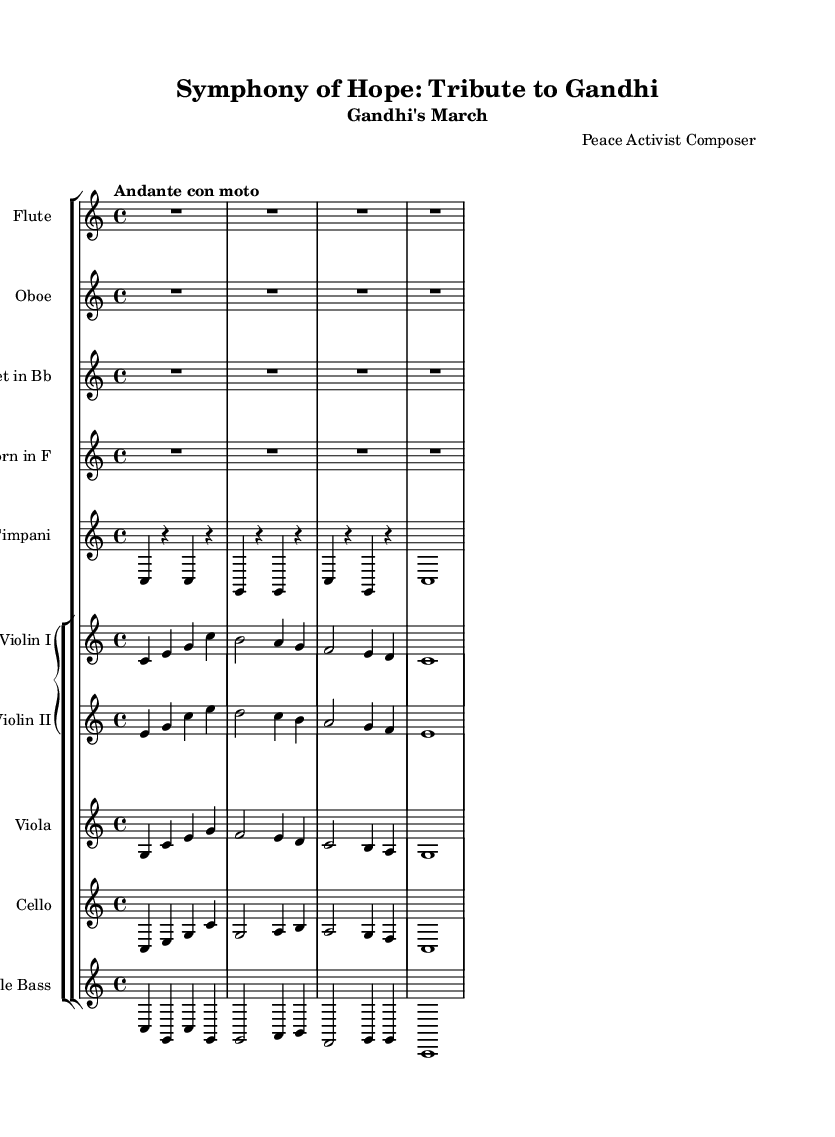What is the key signature of this music? The key signature is C major, which is indicated by the absence of any sharps or flats in the key signature section of the sheet music.
Answer: C major What is the time signature of this music? The time signature is indicated at the beginning of the sheet music, where it shows a 4 over 4, meaning four beats per measure and a quarter note gets one beat.
Answer: 4/4 What is the tempo marking for this piece? The tempo marking is noted in the score with the phrase "Andante con moto," indicating a moderate, flowing pace.
Answer: Andante con moto How many movements are dedicated to historical figures in this symphonic suite? The total number of movements is not explicitly detailed in the provided code, but it can be inferred that each historical figure would correspond to a separate movement, implying there may be multiple figures featured. The answer for the given example is simply derived from the requested concept of the symphony.
Answer: Multiple What instruments are included in the orchestration? The orchestration includes a Flute, Oboe, Clarinet in Bb, Horn in F, Timpani, Violin I, Violin II, Viola, Cello, and Double Bass, as specified in the score.
Answer: Flute, Oboe, Clarinet in Bb, Horn in F, Timpani, Violin I, Violin II, Viola, Cello, Double Bass What is the purpose of this symphony? The purpose of the symphony, as inferred from the title "Symphony of Hope: Tribute to Gandhi," is to honor and reflect the ideals of global peace activists, particularly focusing on Gandhi's contributions to peace and reconciliation.
Answer: Tribute to Gandhi 